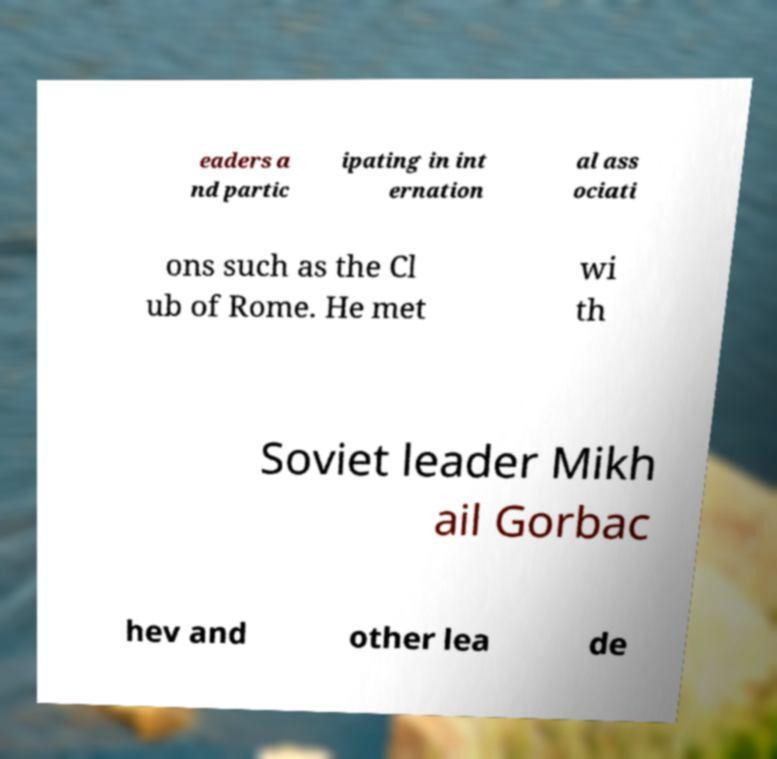I need the written content from this picture converted into text. Can you do that? eaders a nd partic ipating in int ernation al ass ociati ons such as the Cl ub of Rome. He met wi th Soviet leader Mikh ail Gorbac hev and other lea de 